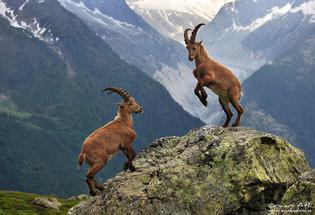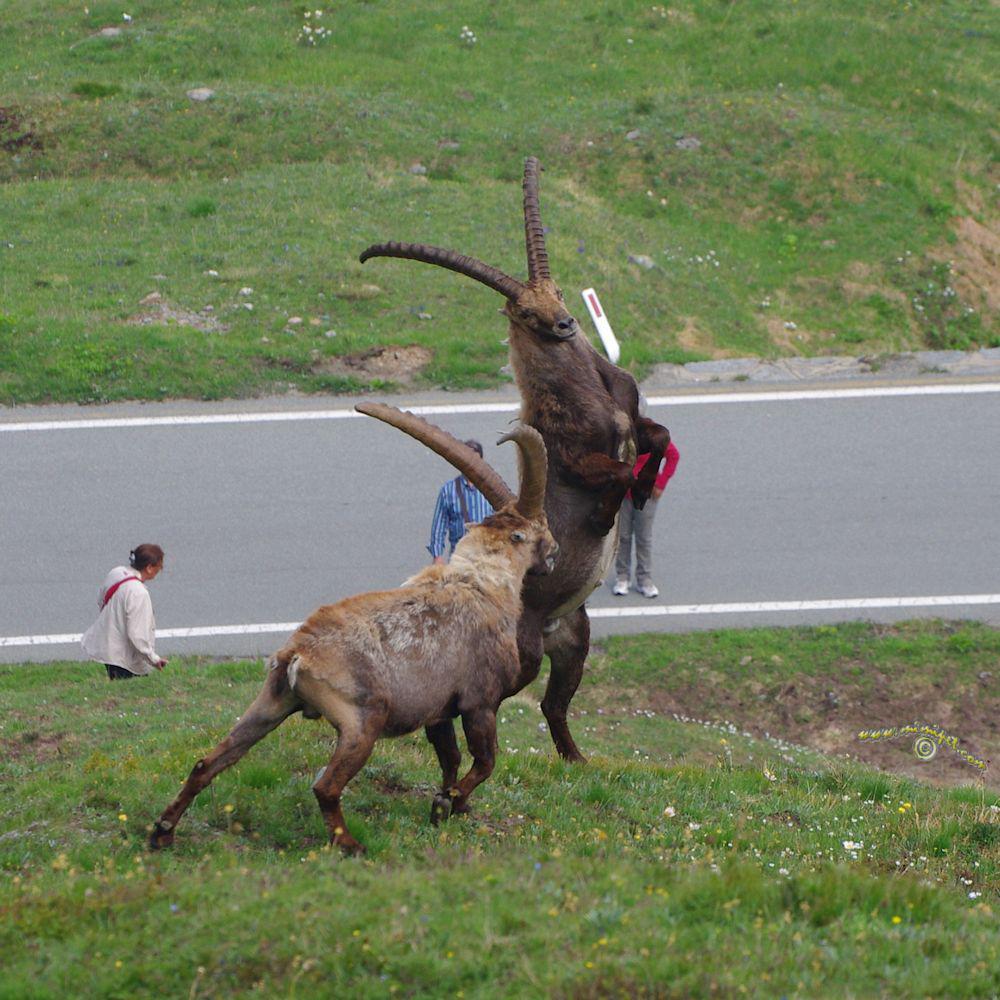The first image is the image on the left, the second image is the image on the right. Considering the images on both sides, is "An ibex has its front paws off the ground." valid? Answer yes or no. Yes. 